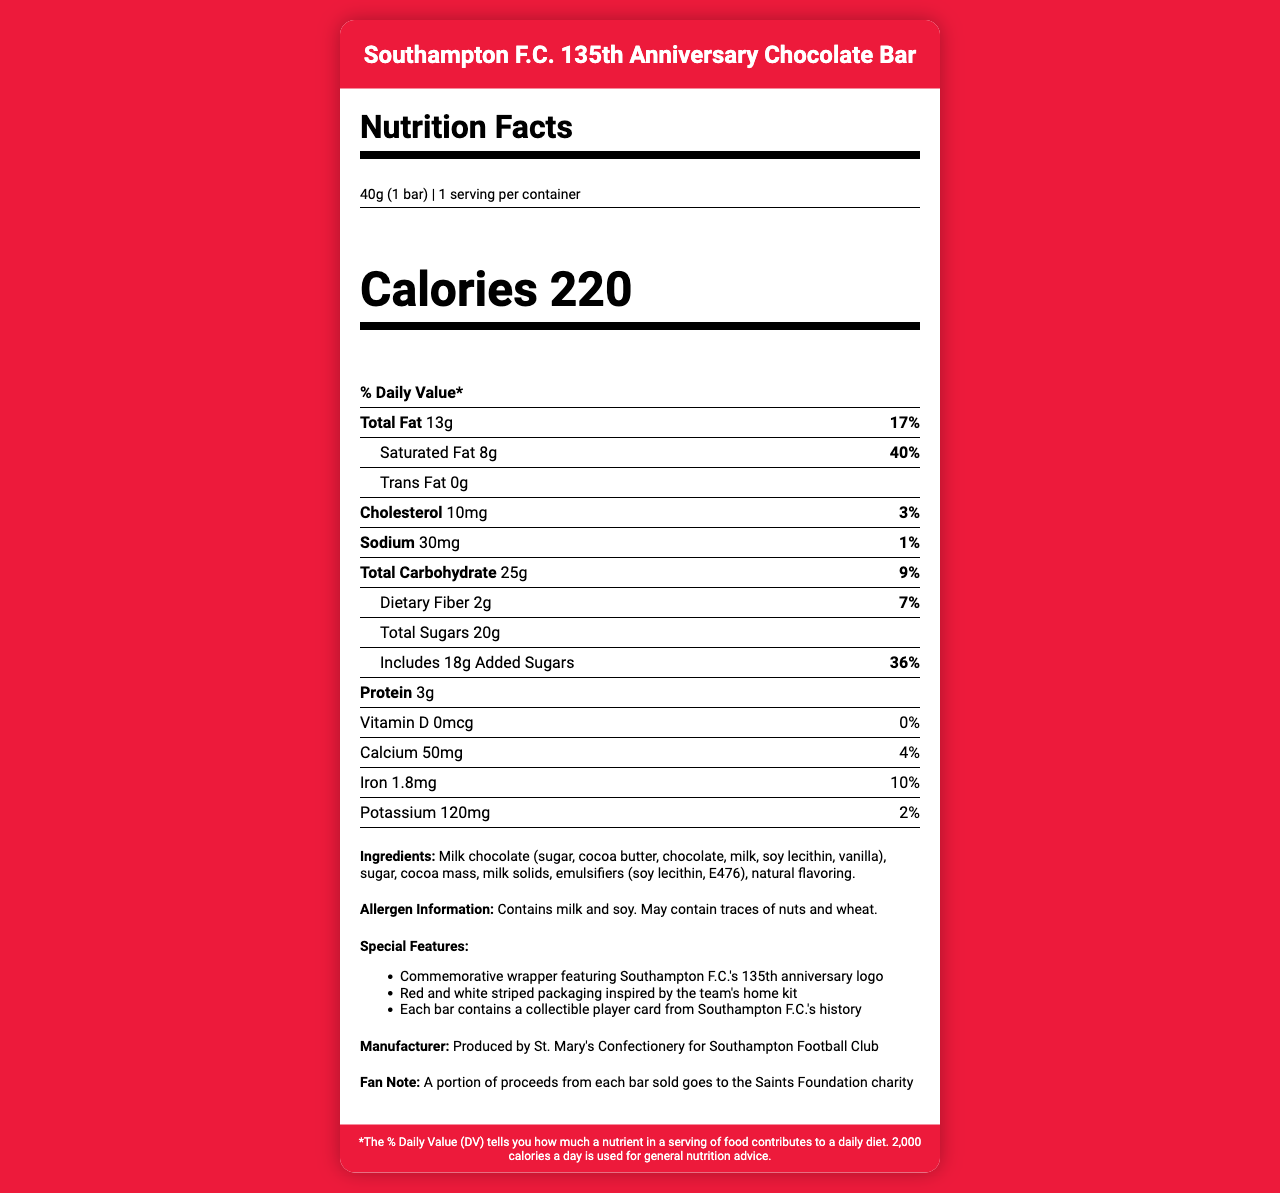How many servings are contained in one chocolate bar? The document specifies that there is one serving per container.
Answer: 1 What is the total amount of fat in one serving of the chocolate bar? The amount of total fat per serving is listed as 13g on the document.
Answer: 13g What percentage of the daily value of saturated fat does one serving of the chocolate bar contain? The document states that one serving contains 40% of the daily value for saturated fat.
Answer: 40% How much calcium is in one serving of the chocolate bar? The document notes that one serving contains 50mg of calcium.
Answer: 50mg List the allergens mentioned in the document. The allergen information section of the document specifies that the bar contains milk and soy and may contain traces of nuts and wheat.
Answer: Milk and soy How many grams of dietary fiber does the chocolate bar have per serving? The document shows that the chocolate bar contains 2g of dietary fiber per serving.
Answer: 2g What is the manufacturer of the chocolate bar? The document mentions that the bar is produced by St. Mary's Confectionery for Southampton Football Club.
Answer: St. Mary's Confectionery for Southampton Football Club How many grams of added sugars are in one serving? The added sugars amount is listed as 18g in the document.
Answer: 18g What is the amount of protein per serving in the chocolate bar? The document indicates that each serving contains 3g of protein.
Answer: 3g What special features does the packaging have? The document notes three special features: the commemorative wrapper with the 135th anniversary logo, red and white striped packaging inspired by the team's home kit, and a collectible player card from Southampton F.C.'s history.
Answer: Commemorative wrapper, red and white striped packaging, collectible player card Does this chocolate bar contain trans fat? The document specifies that the chocolate bar contains 0g of trans fat.
Answer: No What percentage of the daily value for sodium is in one serving of the chocolate bar? The sodium content per serving is listed as 1% of the daily value.
Answer: 1% What is the ingredient listed first in the document? The first ingredient listed in the ingredients section is milk chocolate (sugar, cocoa butter, chocolate, milk, soy lecithin, vanilla).
Answer: Milk chocolate (sugar, cocoa butter, chocolate, milk, soy lecithin, vanilla) Which of the following nutrients have the highest daily value percentage in this chocolate bar? A. Dietary Fiber B. Added Sugars C. Iron Added sugars have 36% of the daily value, higher than dietary fiber (7%) and iron (10%).
Answer: B. Added Sugars Which vitamin is completely absent in the chocolate bar? A. Vitamin A B. Vitamin C C. Vitamin D D. Vitamin B12 The document specifies that there is 0mcg and 0% daily value of Vitamin D.
Answer: C. Vitamin D Is there any iron in the chocolate bar? The document states that the chocolate bar contains 1.8mg of iron, which is 10% of the daily value.
Answer: Yes Summarize the main idea of this document. The document provides comprehensive nutritional information about the chocolate bar, lists ingredients and potential allergens, describes special packaging features, mentions the manufacturer, and notes that proceeds benefit a charity.
Answer: The document is a detailed Nutrition Facts label for the Southampton F.C. 135th Anniversary Chocolate Bar, including information on serving size, nutritional content, ingredients, allergen information, special features, manufacturer details, and a note about charity contributions. What is the exact percentage of Vitamin C in the chocolate bar? The document does not provide any information regarding the Vitamin C content in the chocolate bar.
Answer: Not enough information 